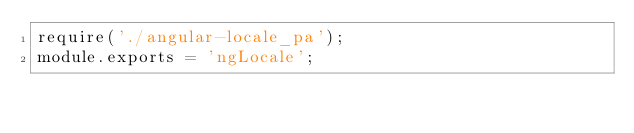Convert code to text. <code><loc_0><loc_0><loc_500><loc_500><_JavaScript_>require('./angular-locale_pa');
module.exports = 'ngLocale';
</code> 